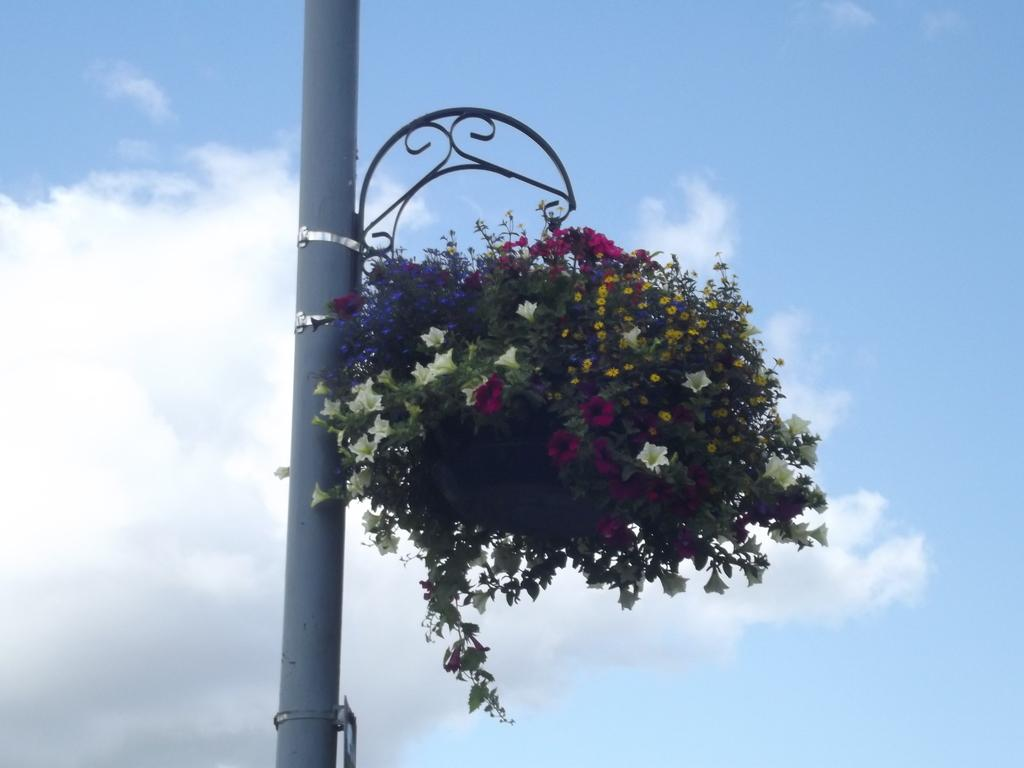What is attached to the pole in the image? There are flowers attached to a pole in the image. What can be seen in the background of the image? There is a sky visible in the background of the image. What type of pest can be seen crawling on the flowers in the image? There are no pests visible in the image; it only shows flowers attached to a pole. What type of camera is being used to take the picture of the flowers in the image? There is no camera visible in the image, as it is a photograph of the flowers and not a picture of someone taking a photograph. 